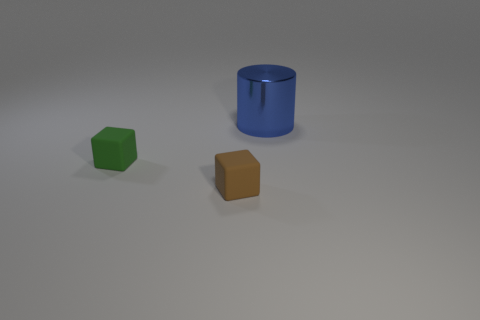Add 1 small matte cubes. How many objects exist? 4 Subtract 1 blocks. How many blocks are left? 1 Subtract all cyan cylinders. Subtract all green balls. How many cylinders are left? 1 Subtract all gray cubes. How many gray cylinders are left? 0 Subtract all small purple cubes. Subtract all brown blocks. How many objects are left? 2 Add 3 tiny brown rubber blocks. How many tiny brown rubber blocks are left? 4 Add 1 small matte cylinders. How many small matte cylinders exist? 1 Subtract all brown cubes. How many cubes are left? 1 Subtract 0 cyan cylinders. How many objects are left? 3 Subtract all cylinders. How many objects are left? 2 